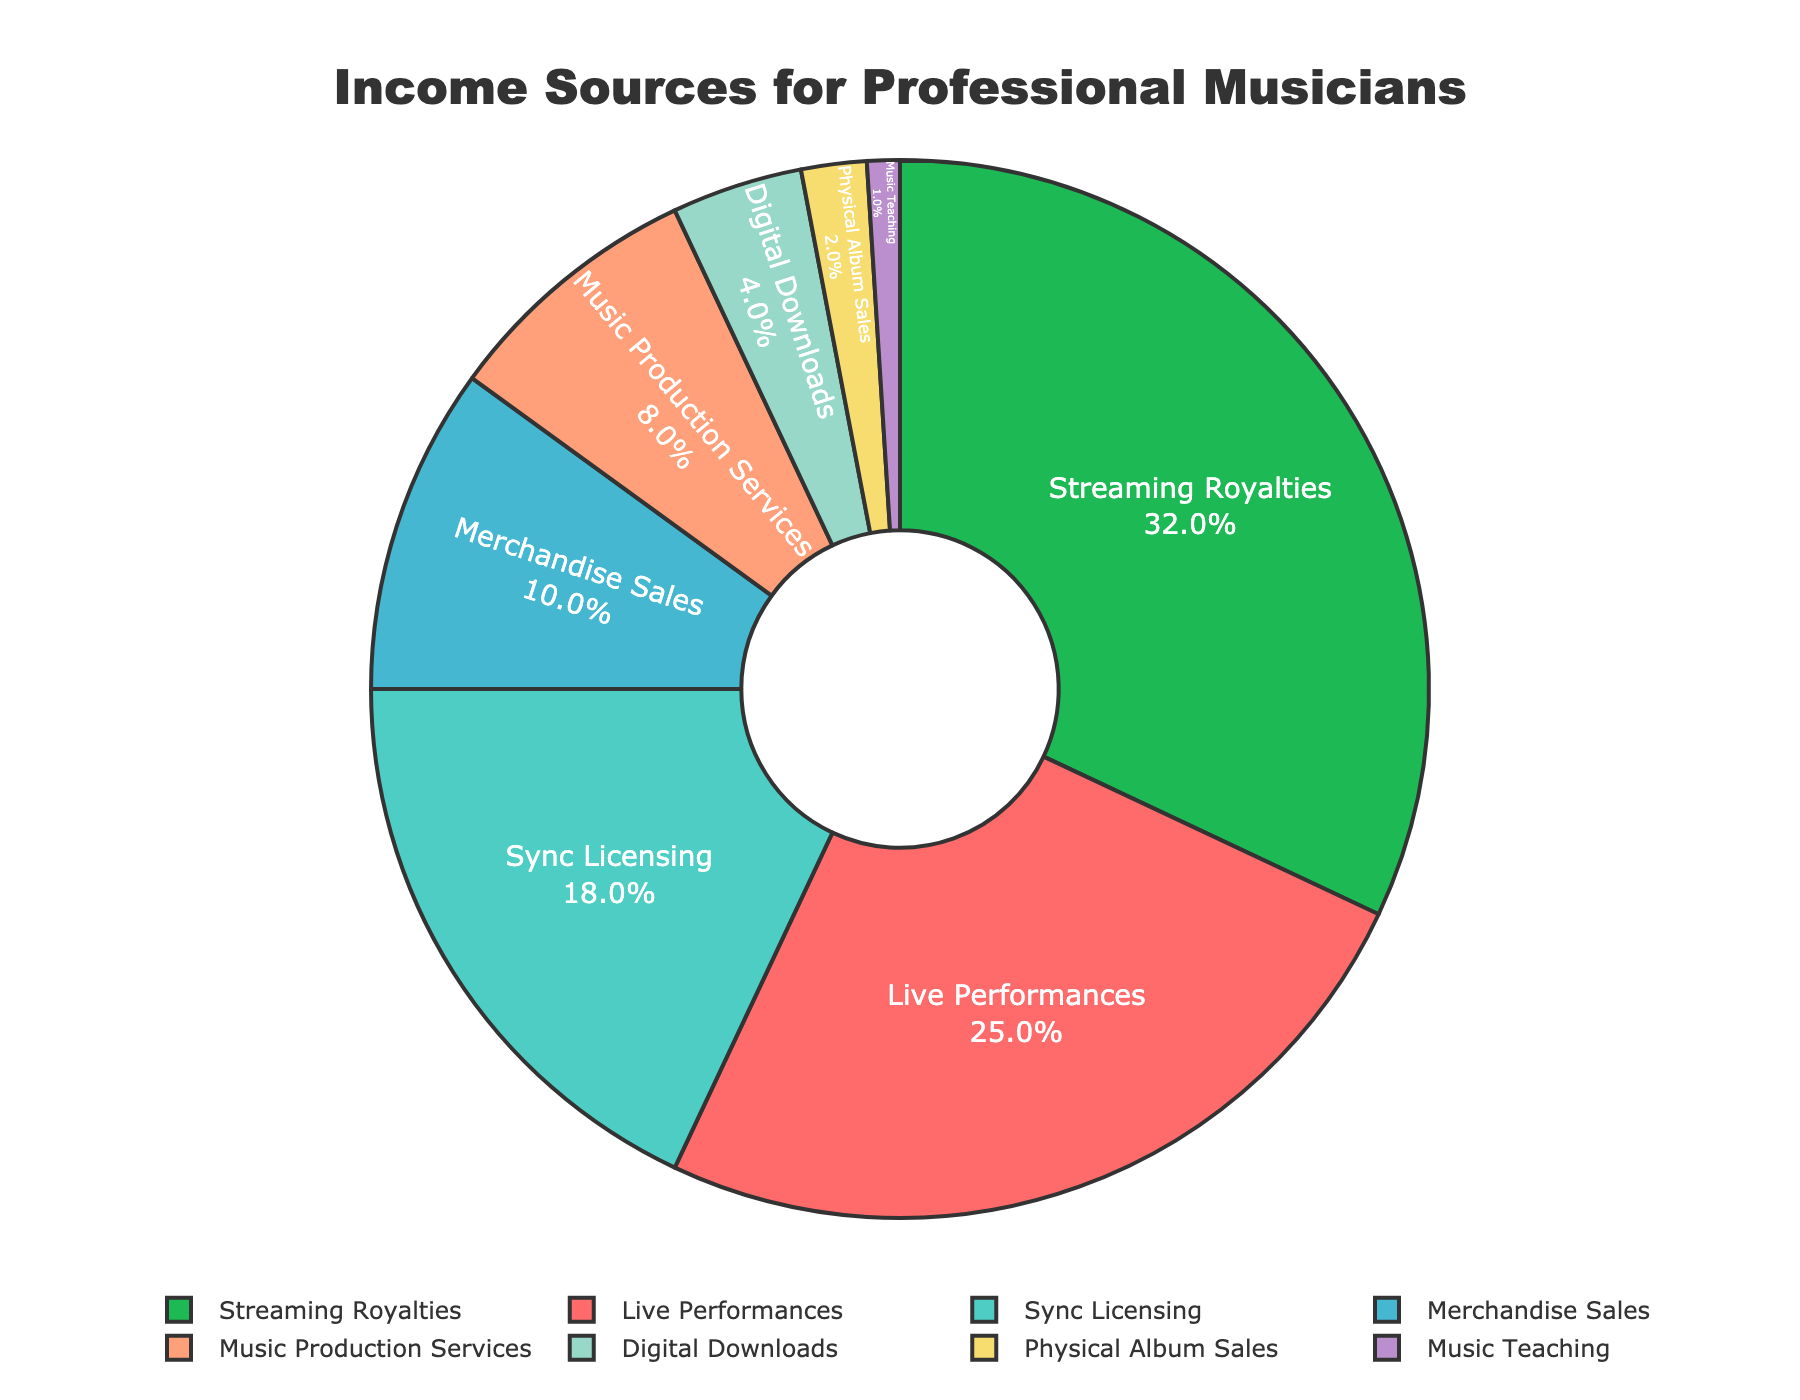What's the most significant source of income for professional musicians based on the pie chart? The segment with the largest percentage will indicate the most significant income source. The 'Streaming Royalties' segment occupies the largest portion of the pie chart at 32%.
Answer: Streaming Royalties Which income source contributes the least to the total income of professional musicians? The segment with the smallest percentage will be the least contributing source. The 'Music Teaching' segment is the smallest, contributing 1% of the total income.
Answer: Music Teaching What is the combined percentage of income from 'Live Performances' and 'Merchandise Sales'? Add the percentages from 'Live Performances' and 'Merchandise Sales'. 'Live Performances' contributes 25% and 'Merchandise Sales' contributes 10%. Therefore, the combined percentage is 25% + 10% = 35%.
Answer: 35% How does the percentage of income from 'Physical Album Sales' compare to 'Digital Downloads'? Compare the percentages of these two income sources. 'Physical Album Sales' is 2%, while 'Digital Downloads' is 4%. Therefore, 'Digital Downloads' is twice as much as 'Physical Album Sales'.
Answer: Digital Downloads is twice as much as Physical Album Sales What percentage of income is derived from non-performance related sources (Streaming Royalties, Sync Licensing, Merchandise Sales, Music Production Services, Digital Downloads, Physical Album Sales, Music Teaching)? Add the percentages from all the non-performance related sources. 'Streaming Royalties (32%) + Sync Licensing (18%) + Merchandise Sales (10%) + Music Production Services (8%) + Digital Downloads (4%) + Physical Album Sales (2%) + Music Teaching (1%) = 75%'.
Answer: 75% Which segment is visually represented by the color green? Identify the segment that has the color green. The 'Streaming Royalties' segment is colored green.
Answer: Streaming Royalties By how much does the income from 'Sync Licensing' exceed 'Music Production Services'? Subtract the percentage of 'Music Production Services' from 'Sync Licensing'. 'Sync Licensing' is at 18%, and 'Music Production Services' is at 8%. Therefore, 18% - 8% = 10%.
Answer: 10% What is the total percentage of income derived from sales-based sources (Merchandise Sales, Digital Downloads, Physical Album Sales)? Add the percentages from sales-based sources. 'Merchandise Sales (10%) + Digital Downloads (4%) + Physical Album Sales (2%) = 16%'.
Answer: 16% What is the difference in percentage points between the largest income source and the smallest income source? Subtract the percentage of the smallest source (Music Teaching, 1%) from the largest source (Streaming Royalties, 32%). Therefore, 32% - 1% = 31%.
Answer: 31% Which two income sources together make up more than half of the total income and what are their percentages? Sum the percentages of different combinations to find which two sources exceed 50%. 'Streaming Royalties (32%) + Live Performances (25%) = 57%' exceeds half. No other combination of two sources exceeds 50%.
Answer: Streaming Royalties and Live Performances, 57% 